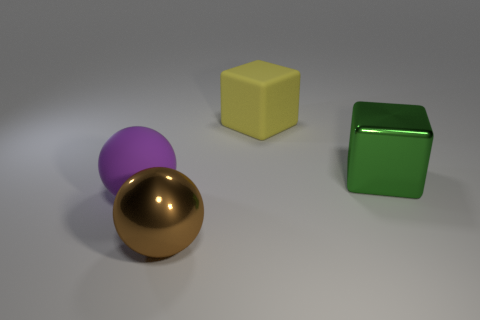What material is the thing behind the metal cube?
Your response must be concise. Rubber. Is there any other thing that has the same size as the green cube?
Offer a very short reply. Yes. There is a big purple matte thing; are there any shiny balls on the left side of it?
Make the answer very short. No. There is a green thing; what shape is it?
Offer a terse response. Cube. What number of objects are big purple rubber objects in front of the green block or blocks?
Make the answer very short. 3. Is the color of the large matte sphere the same as the metallic object left of the green thing?
Offer a terse response. No. There is another matte thing that is the same shape as the green object; what color is it?
Your response must be concise. Yellow. Is the large purple ball made of the same material as the big cube in front of the yellow matte block?
Provide a succinct answer. No. What is the color of the rubber ball?
Provide a succinct answer. Purple. What color is the metal thing right of the big thing behind the block in front of the big yellow matte cube?
Keep it short and to the point. Green. 